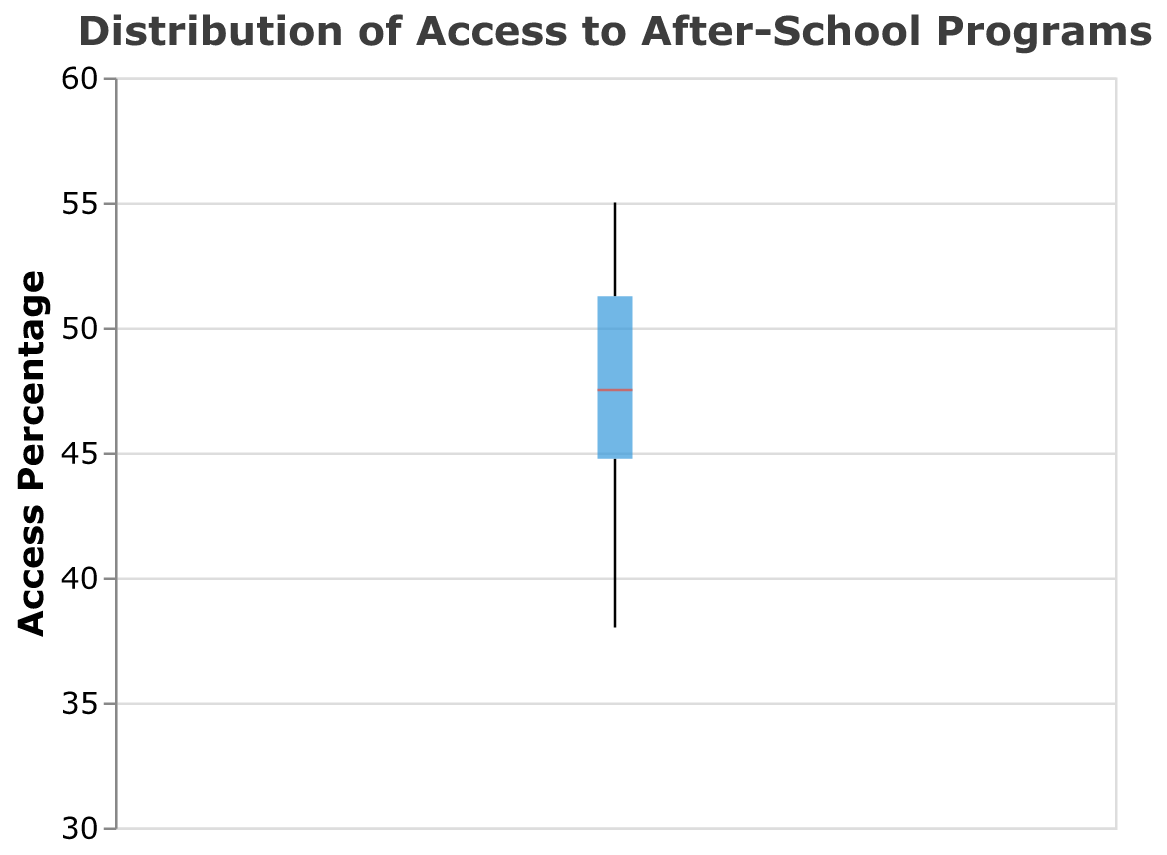What is the title of the box plot? The title of the box plot is displayed at the top and summarizes the main topic. The title provided in the plot is "Distribution of Access to After-School Programs."
Answer: Distribution of Access to After-School Programs What is the range of the y-axis in the box plot? The range of the y-axis indicates the values from minimum to maximum that are being considered in the data. By observing the scale on the y-axis, we can see that it ranges from 30% to 60%.
Answer: 30 to 60 What is the median access percentage based on the box plot? The median is represented by a line inside the box, which in this box plot is colored red. By looking at the position of the red line, we can determine the approximate median value.
Answer: 47 (approximate) How many data points are shown as outliers in the box plot? Outliers are represented by individual points that fall outside the overall box plot structure. By counting the number of individual points visible in the plot, we can determine the number of outliers.
Answer: 0 Which school district has the highest access percentage to after-school programs? To find the school district with the highest access percentage, we look at the top value within the box plot. According to the data provided, Charlotte has the highest value of 55%.
Answer: Charlotte Which school district has the lowest access percentage to after-school programs? To find the school district with the lowest access percentage, we look at the bottom value within the box plot. According to the data provided, Chicago has the lowest value of 38%.
Answer: Chicago What is the interquartile range (IQR) in the box plot? The interquartile range (IQR) is the range between the first quartile (Q1) and the third quartile (Q3). By identifying these positions on the y-axis based on the box plot's box boundaries, we can calculate the IQR.
Answer: ~46 to ~51 (5%) How does Seattle's access percentage compare to the median? Seattle's access percentage and the plot's median value can be compared to understand how it deviates from the central tendency. Seattle has a value of 54%, which is higher than the median of 47%.
Answer: Higher Which school districts have access percentages above 50%? By examining the box plot, we can identify the specific school districts that have access percentages above the 50% mark. These are: Los Angeles, San Diego, San Jose, Charlotte, Seattle, and Washington DC.
Answer: Los Angeles, San Diego, San Jose, Charlotte, Seattle, Washington DC What is the mean access percentage of all school districts? Calculate the mean by summing all access percentages and then dividing by the number of school districts. The total sum is 943, and there are 20 school districts, so the mean is 943 / 20 = 47.15.
Answer: 47.15 